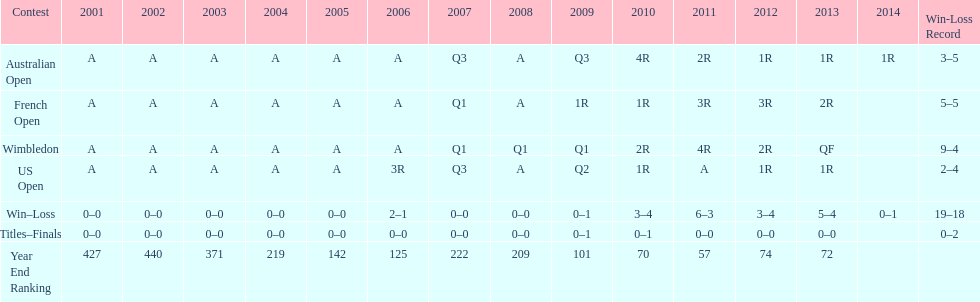In what year was the top year-end ranking accomplished? 2011. 